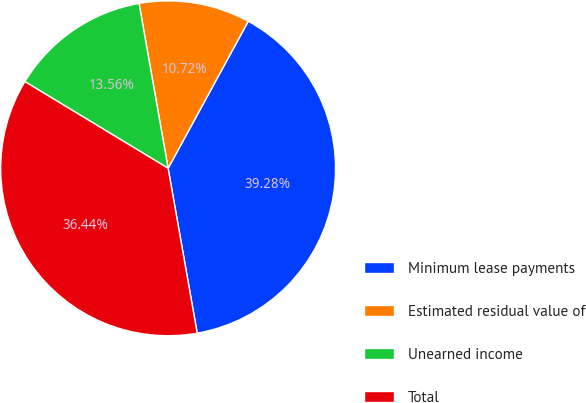Convert chart to OTSL. <chart><loc_0><loc_0><loc_500><loc_500><pie_chart><fcel>Minimum lease payments<fcel>Estimated residual value of<fcel>Unearned income<fcel>Total<nl><fcel>39.28%<fcel>10.72%<fcel>13.56%<fcel>36.44%<nl></chart> 